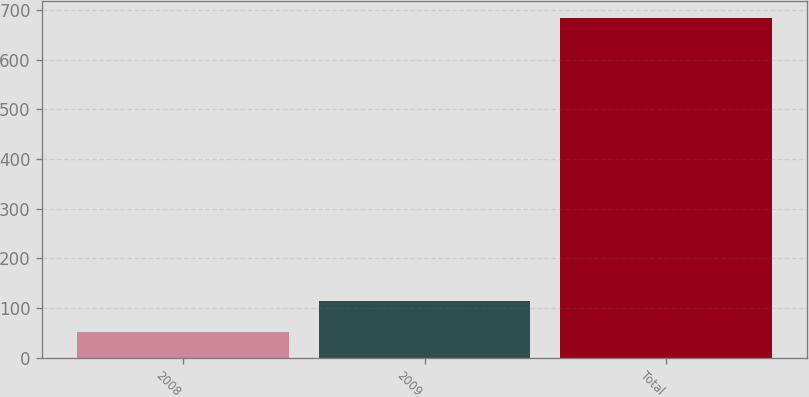Convert chart. <chart><loc_0><loc_0><loc_500><loc_500><bar_chart><fcel>2008<fcel>2009<fcel>Total<nl><fcel>51<fcel>114.2<fcel>683<nl></chart> 